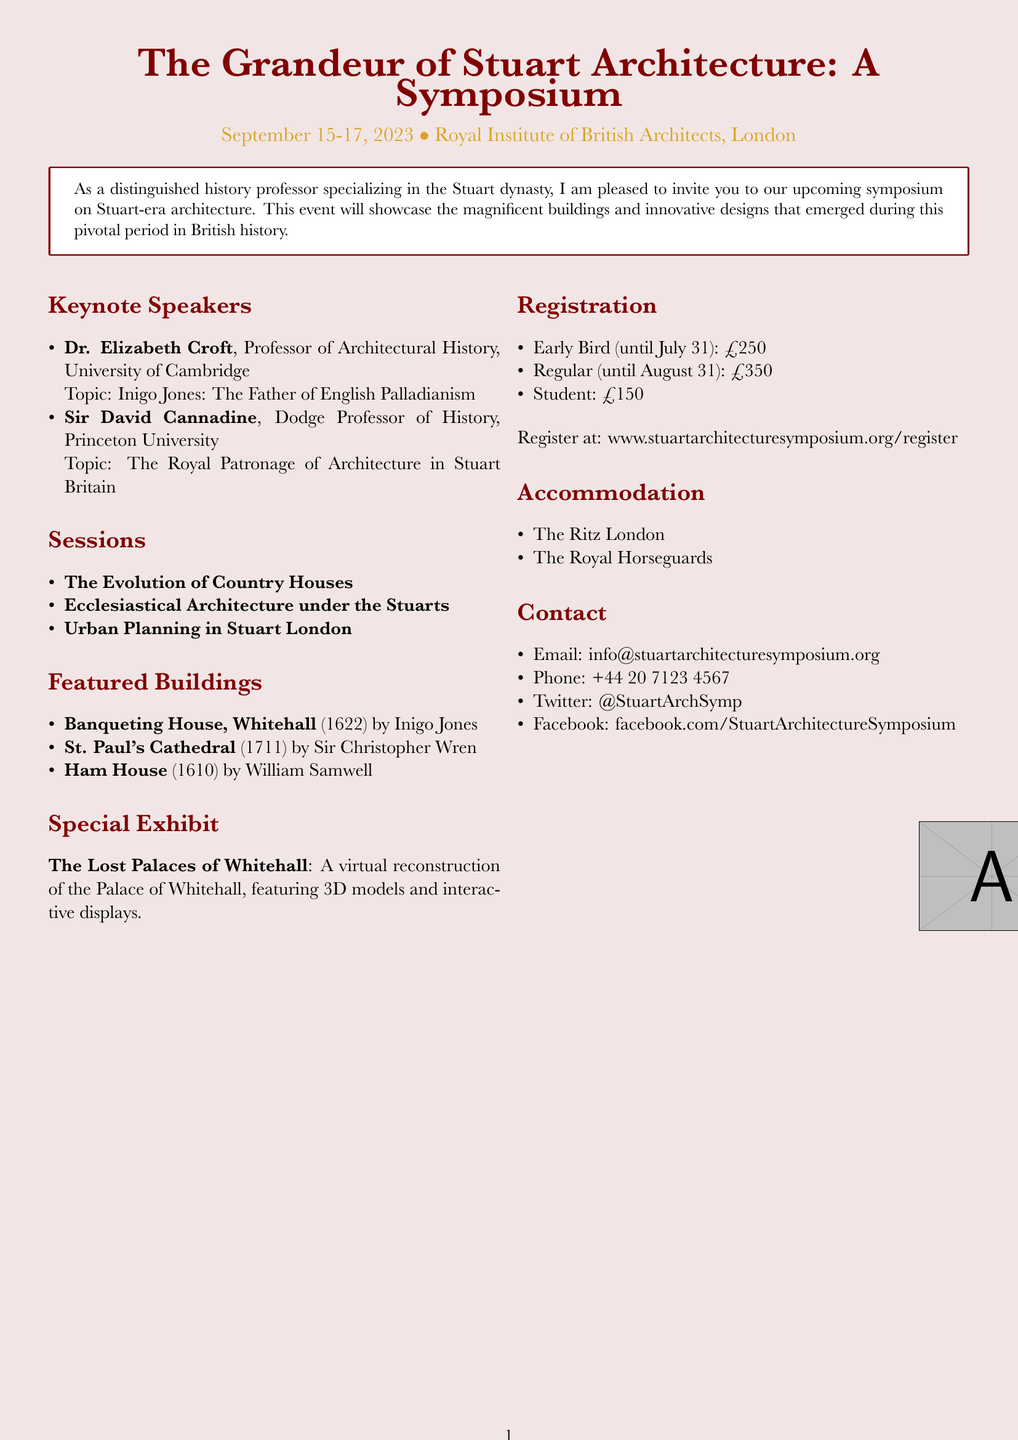What are the dates of the symposium? The dates of the symposium are specified in the document.
Answer: September 15-17, 2023 Who is the keynote speaker discussing Inigo Jones? The document lists keynote speakers along with their topics.
Answer: Dr. Elizabeth Croft What is the registration fee for students? The document provides fee information regarding registration types.
Answer: £150 Which building was completed in 1711? The featured buildings list includes year of completion for each.
Answer: St. Paul's Cathedral What is the title of the special exhibit? The document mentions a special exhibit and provides its title.
Answer: The Lost Palaces of Whitehall How many sessions are listed in the symposium? The document explicitly states the number of sessions provided.
Answer: Three What architectural style is the Banqueting House associated with? The document describes notable buildings and their architectural styles.
Answer: English Palladian architecture What is the address of The Ritz London? The accommodation options provide specific addresses.
Answer: 150 Piccadilly, St. James's, London W1J 9BR When is the early bird registration deadline? The registration information includes deadline dates.
Answer: July 31, 2023 